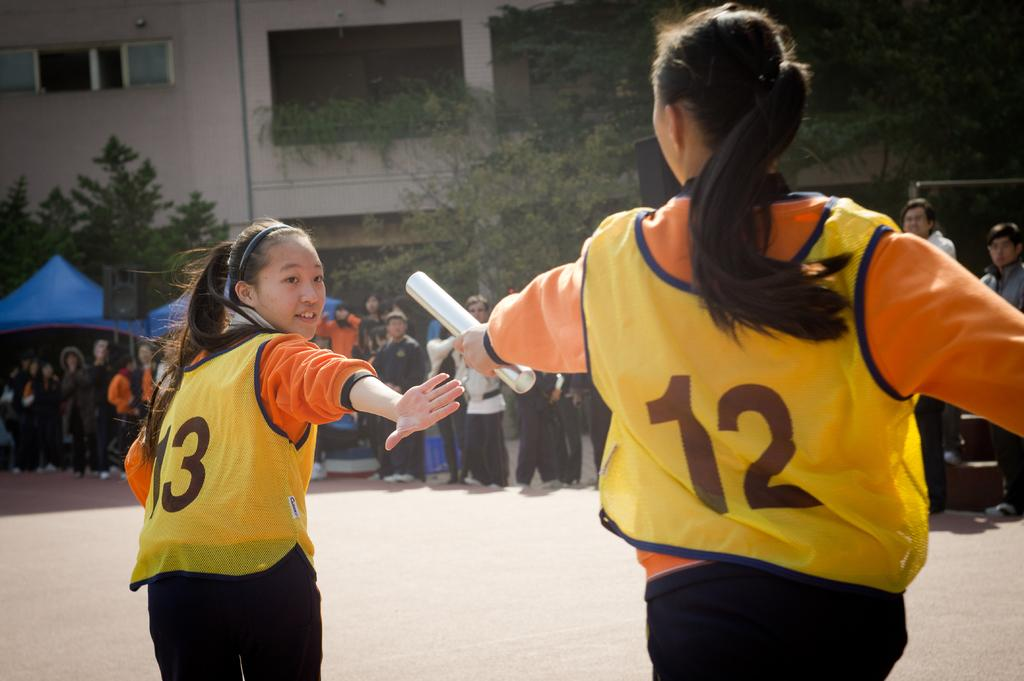<image>
Give a short and clear explanation of the subsequent image. Two people racing with yellow number vests 13 and 12. 